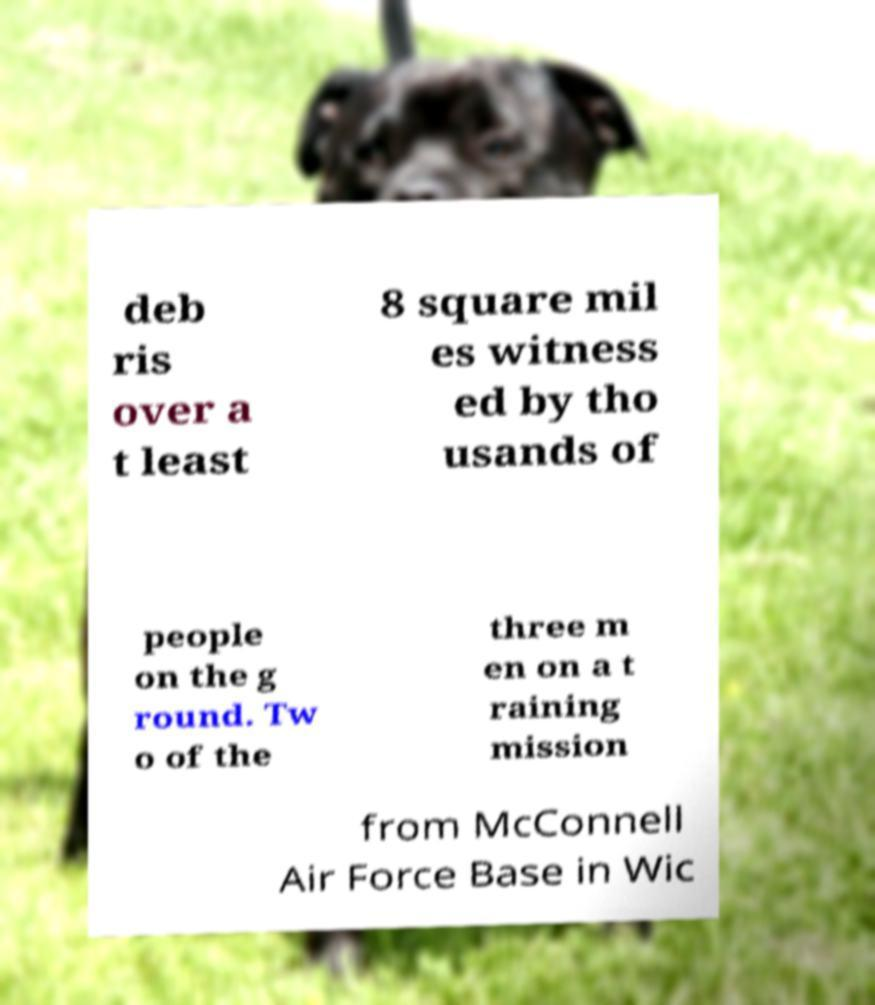Could you extract and type out the text from this image? deb ris over a t least 8 square mil es witness ed by tho usands of people on the g round. Tw o of the three m en on a t raining mission from McConnell Air Force Base in Wic 